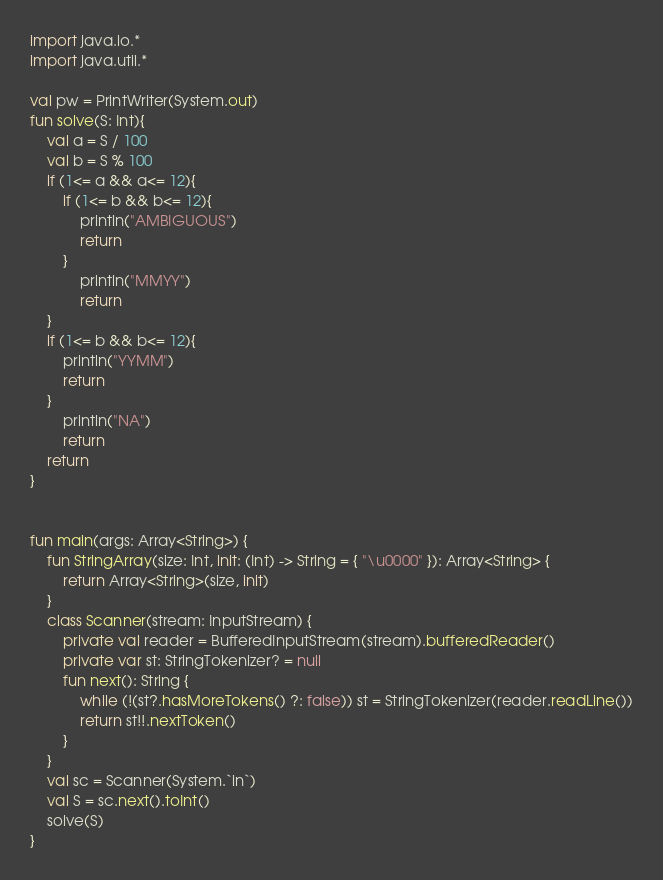<code> <loc_0><loc_0><loc_500><loc_500><_Kotlin_>import java.io.*
import java.util.*

val pw = PrintWriter(System.out)
fun solve(S: Int){
    val a = S / 100
    val b = S % 100
    if (1<= a && a<= 12){
        if (1<= b && b<= 12){
            println("AMBIGUOUS")
            return
        }
            println("MMYY")
            return
    }
    if (1<= b && b<= 12){
        println("YYMM")
        return
    }
        println("NA")
        return
    return
}


fun main(args: Array<String>) {
    fun StringArray(size: Int, init: (Int) -> String = { "\u0000" }): Array<String> {
        return Array<String>(size, init)
    }
    class Scanner(stream: InputStream) {
        private val reader = BufferedInputStream(stream).bufferedReader()
        private var st: StringTokenizer? = null
        fun next(): String {
            while (!(st?.hasMoreTokens() ?: false)) st = StringTokenizer(reader.readLine())
            return st!!.nextToken()
        }
    }
    val sc = Scanner(System.`in`)
    val S = sc.next().toInt()
    solve(S)
}

</code> 